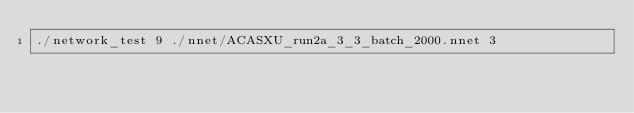<code> <loc_0><loc_0><loc_500><loc_500><_Bash_>./network_test 9 ./nnet/ACASXU_run2a_3_3_batch_2000.nnet 3</code> 